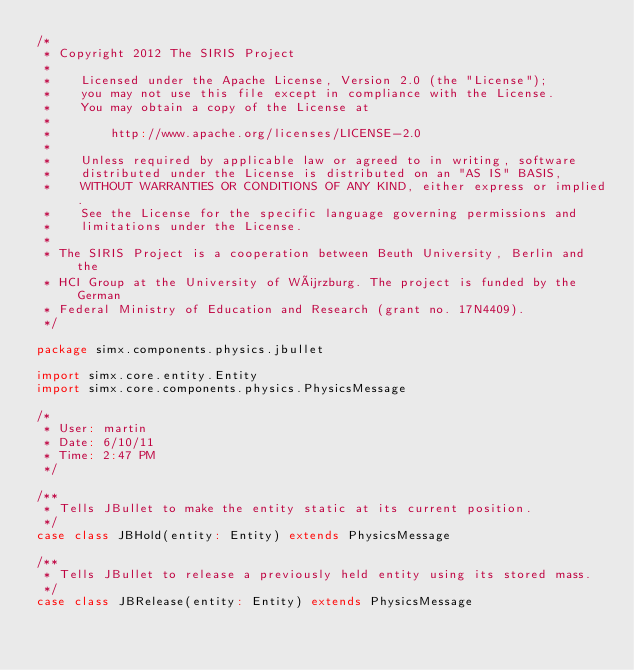<code> <loc_0><loc_0><loc_500><loc_500><_Scala_>/*
 * Copyright 2012 The SIRIS Project
 *
 *    Licensed under the Apache License, Version 2.0 (the "License");
 *    you may not use this file except in compliance with the License.
 *    You may obtain a copy of the License at
 *
 *        http://www.apache.org/licenses/LICENSE-2.0
 *
 *    Unless required by applicable law or agreed to in writing, software
 *    distributed under the License is distributed on an "AS IS" BASIS,
 *    WITHOUT WARRANTIES OR CONDITIONS OF ANY KIND, either express or implied.
 *    See the License for the specific language governing permissions and
 *    limitations under the License.
 *
 * The SIRIS Project is a cooperation between Beuth University, Berlin and the
 * HCI Group at the University of Würzburg. The project is funded by the German
 * Federal Ministry of Education and Research (grant no. 17N4409).
 */

package simx.components.physics.jbullet

import simx.core.entity.Entity
import simx.core.components.physics.PhysicsMessage

/*
 * User: martin
 * Date: 6/10/11
 * Time: 2:47 PM
 */

/**
 * Tells JBullet to make the entity static at its current position.
 */
case class JBHold(entity: Entity) extends PhysicsMessage

/**
 * Tells JBullet to release a previously held entity using its stored mass.
 */
case class JBRelease(entity: Entity) extends PhysicsMessage

</code> 